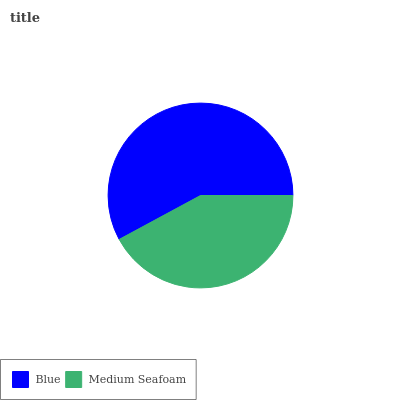Is Medium Seafoam the minimum?
Answer yes or no. Yes. Is Blue the maximum?
Answer yes or no. Yes. Is Medium Seafoam the maximum?
Answer yes or no. No. Is Blue greater than Medium Seafoam?
Answer yes or no. Yes. Is Medium Seafoam less than Blue?
Answer yes or no. Yes. Is Medium Seafoam greater than Blue?
Answer yes or no. No. Is Blue less than Medium Seafoam?
Answer yes or no. No. Is Blue the high median?
Answer yes or no. Yes. Is Medium Seafoam the low median?
Answer yes or no. Yes. Is Medium Seafoam the high median?
Answer yes or no. No. Is Blue the low median?
Answer yes or no. No. 